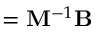<formula> <loc_0><loc_0><loc_500><loc_500>{ \Phi } = { M } ^ { - 1 } { B }</formula> 